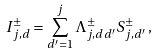<formula> <loc_0><loc_0><loc_500><loc_500>I _ { j , d } ^ { \pm } = \sum _ { d ^ { \prime } = 1 } ^ { j } \Lambda _ { j , d d ^ { \prime } } ^ { \pm } S _ { j , d ^ { \prime } } ^ { \pm } \, ,</formula> 